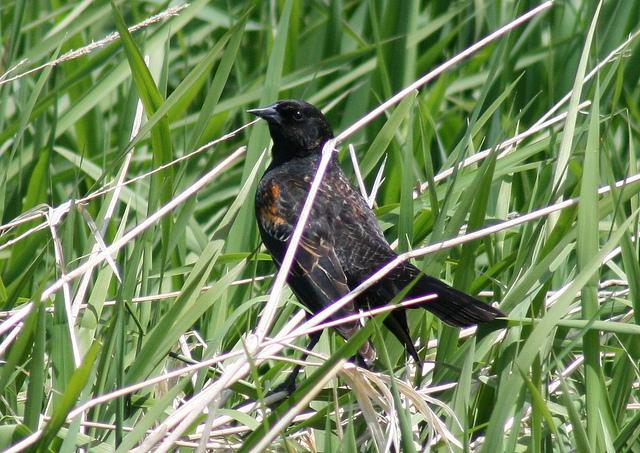Does this animal look like someone's pet?
Write a very short answer. No. Is the bird black?
Write a very short answer. Yes. Is the bird flying?
Answer briefly. No. Where is the bird standing?
Be succinct. Grass. What is the bird standing on?
Write a very short answer. Grass. 